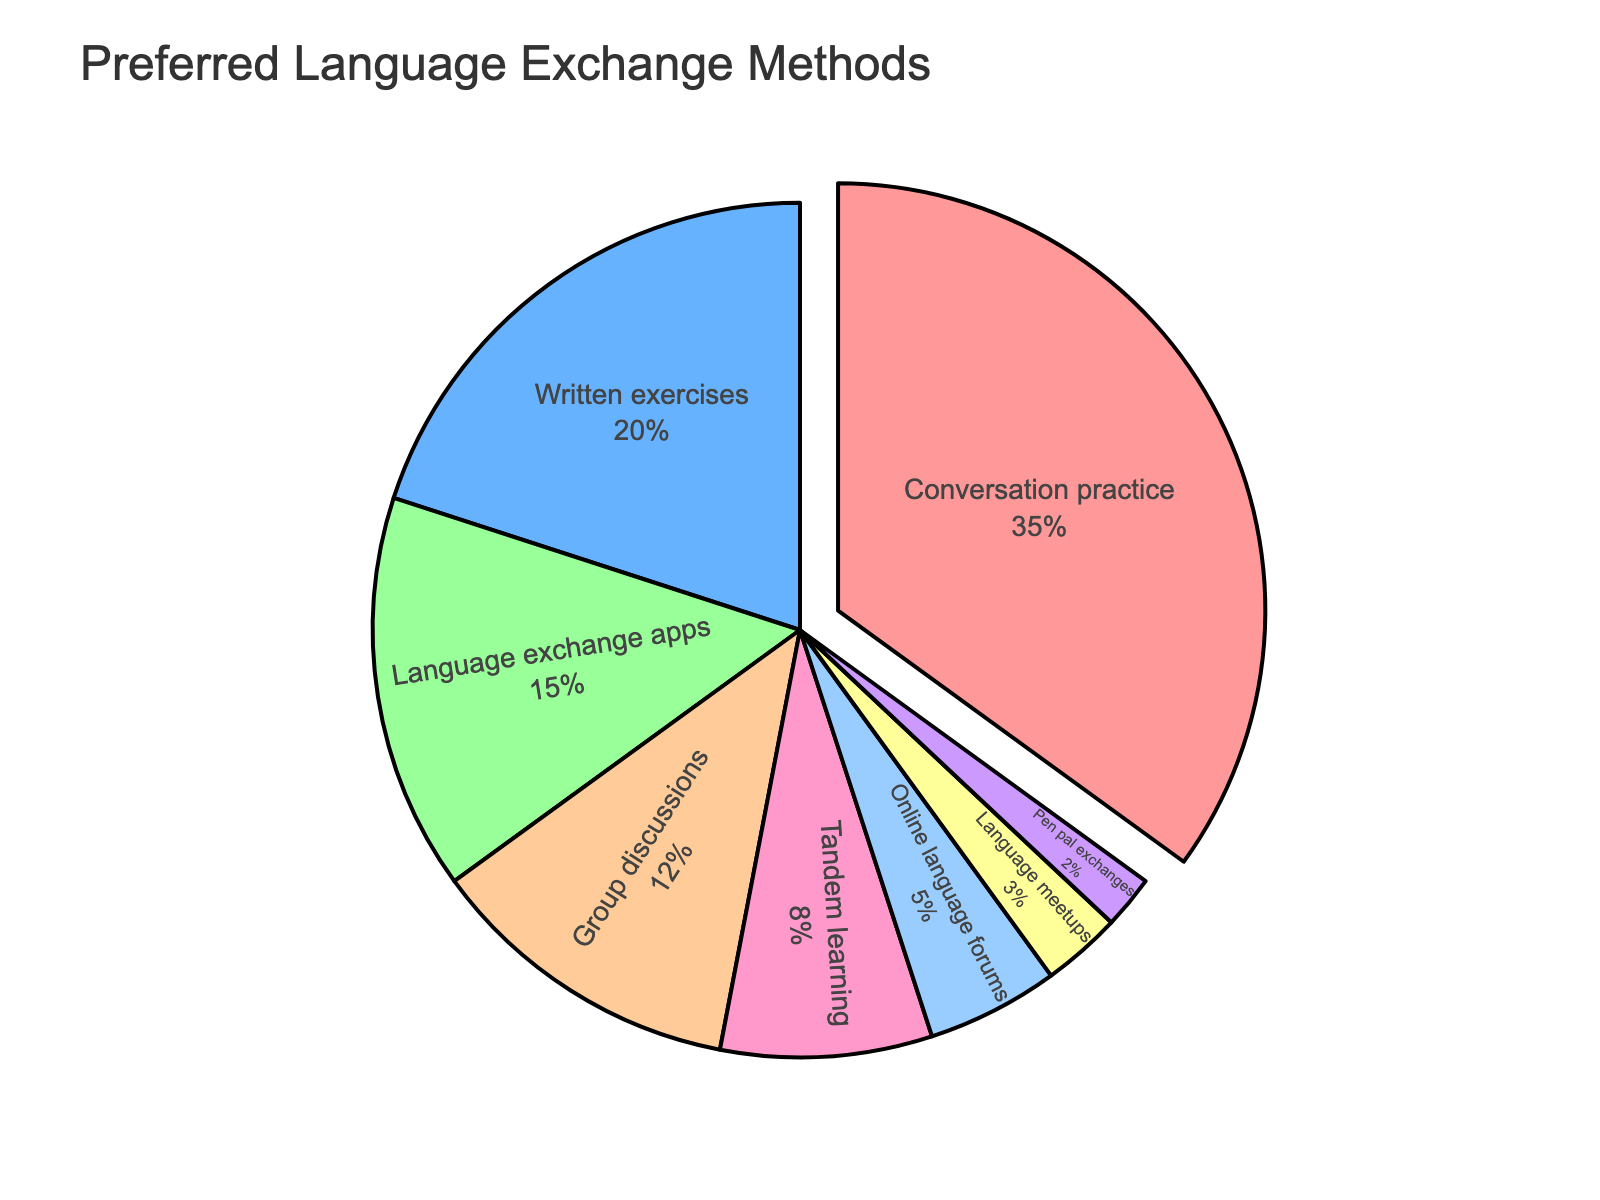What's the most preferred language exchange method among participants? Look at the segment of the pie chart with the largest size. The largest segment corresponds to "Conversation practice" at 35%.
Answer: Conversation practice What's the least preferred language exchange method among participants? Look at the segment of the pie chart with the smallest size. The smallest segment corresponds to "Pen pal exchanges" at 2%.
Answer: Pen pal exchanges How do the percentages of "Conversation practice" and "Written exercises" compare? Identify both segments and compare their sizes or values. "Conversation practice" is 35%, and "Written exercises" is 20%. "Conversation practice" is larger.
Answer: Conversation practice is larger What is the sum of the percentages for "Group discussions" and "Tandem learning"? Find the values for both segments: "Group discussions" is 12% and "Tandem learning" is 8%. Sum them up: 12% + 8% = 20%.
Answer: 20% What is the combined percentage of all methods related to writing (Written exercises, Pen pal exchanges)? Identify and sum the values for all methods related to writing: "Written exercises" is 20% and "Pen pal exchanges" is 2%. Sum them up: 20% + 2% = 22%.
Answer: 22% Which method has a percentage closest to "Tandem learning"? Identify the percentage of "Tandem learning" (8%) and compare it to the other segments. "Online language forums" at 5% and "Group discussions" at 12% are the nearest. "Online language forums" at 5% is closest.
Answer: Online language forums How much larger is "Conversation practice" compared to "Group discussions"? Compare the values: "Conversation practice" is 35% and "Group discussions" is 12%. Subtract the smaller value from the larger value: 35% - 12% = 23%.
Answer: 23% If you added the percentages for "Language exchange apps" and "Language meetups," would it exceed "Written exercises"? Find the values and sum them: "Language exchange apps" is 15% and "Language meetups" is 3%, summing up to 18%. Compare this with "Written exercises" at 20%. 18% < 20%.
Answer: No Which method is represented by the blue color in the pie chart? Identify segments in blue. The "Language exchange apps" segment is blue as per the described color sequence.
Answer: Language exchange apps 